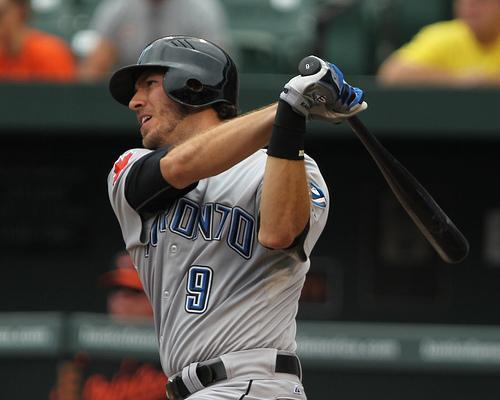How many players are there?
Give a very brief answer. 1. 